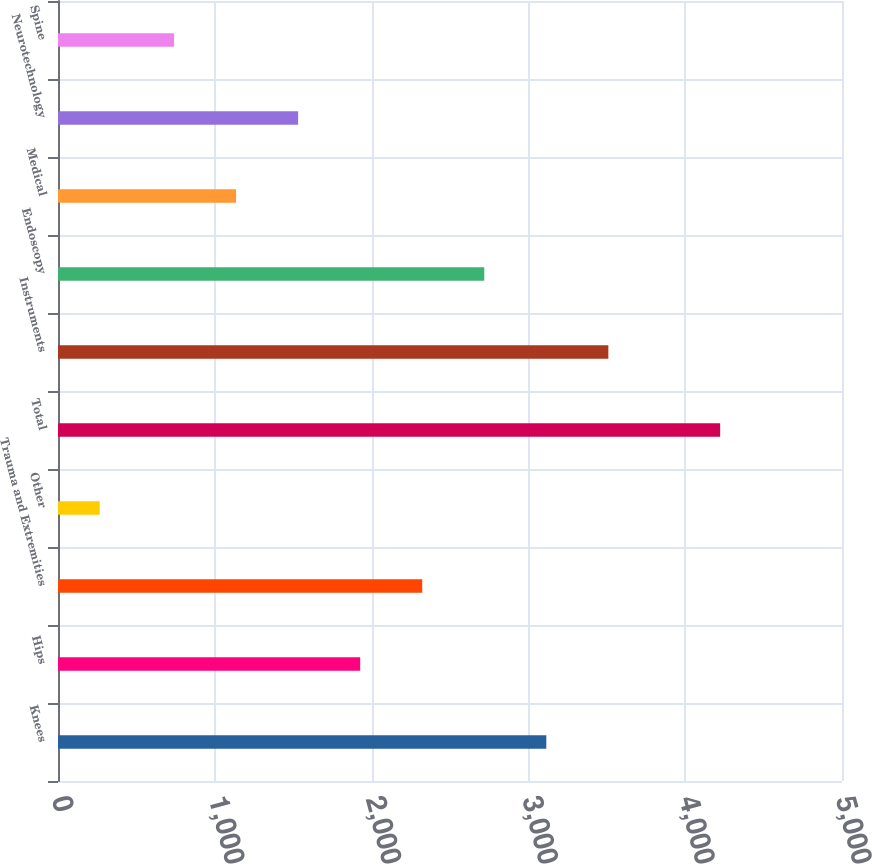Convert chart to OTSL. <chart><loc_0><loc_0><loc_500><loc_500><bar_chart><fcel>Knees<fcel>Hips<fcel>Trauma and Extremities<fcel>Other<fcel>Total<fcel>Instruments<fcel>Endoscopy<fcel>Medical<fcel>Neurotechnology<fcel>Spine<nl><fcel>3114.2<fcel>1927.1<fcel>2322.8<fcel>266<fcel>4223<fcel>3509.9<fcel>2718.5<fcel>1135.7<fcel>1531.4<fcel>740<nl></chart> 